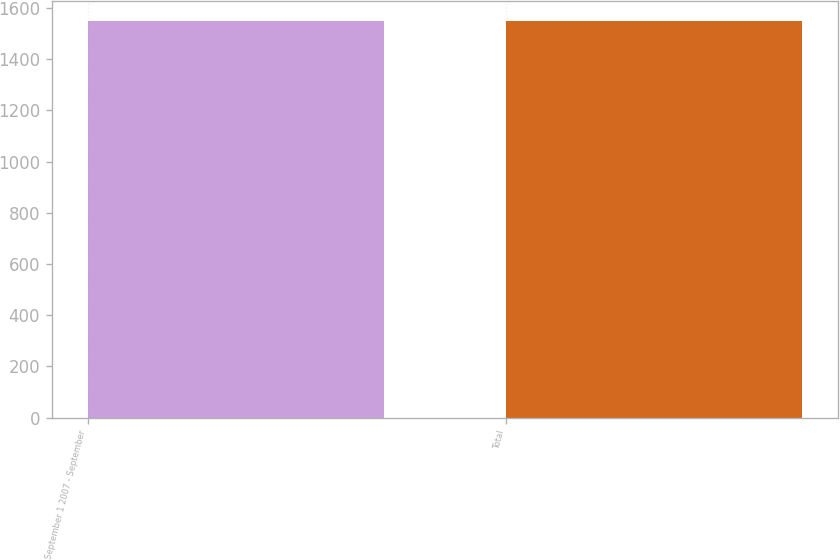Convert chart. <chart><loc_0><loc_0><loc_500><loc_500><bar_chart><fcel>September 1 2007 - September<fcel>Total<nl><fcel>1548<fcel>1548.1<nl></chart> 